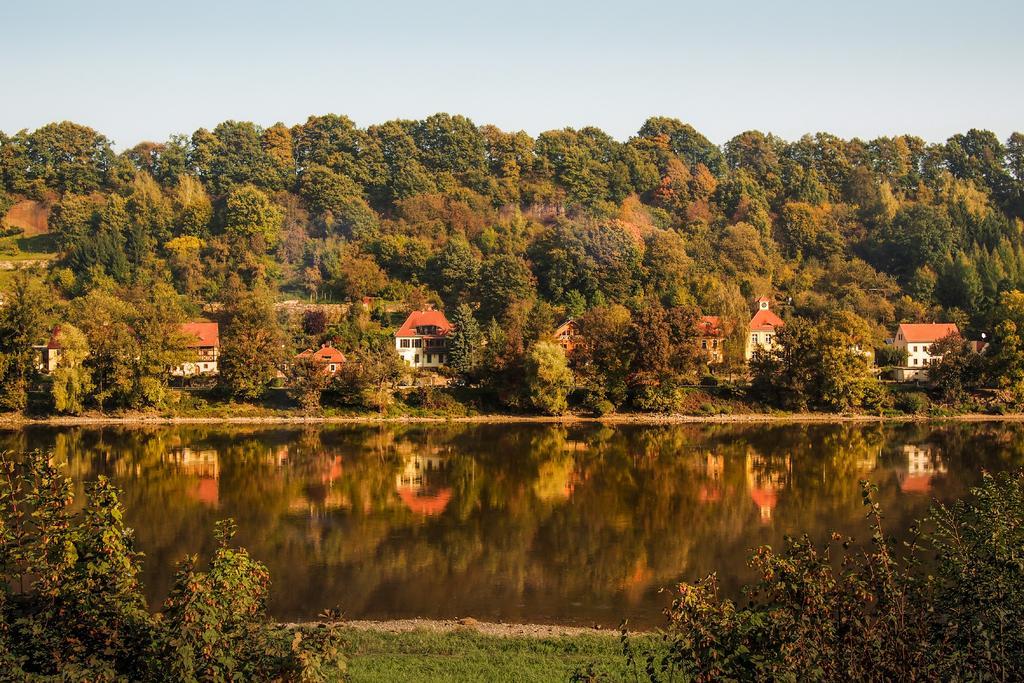Describe this image in one or two sentences. In this image we can see there are houses, trees, grass and water. And there is the sky in the background. 